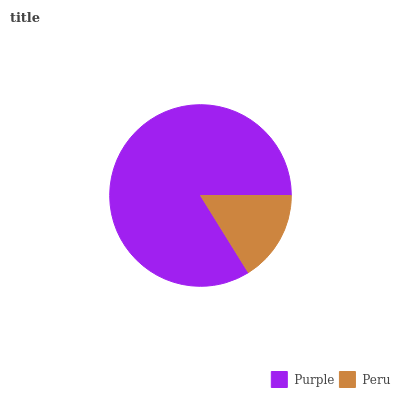Is Peru the minimum?
Answer yes or no. Yes. Is Purple the maximum?
Answer yes or no. Yes. Is Peru the maximum?
Answer yes or no. No. Is Purple greater than Peru?
Answer yes or no. Yes. Is Peru less than Purple?
Answer yes or no. Yes. Is Peru greater than Purple?
Answer yes or no. No. Is Purple less than Peru?
Answer yes or no. No. Is Purple the high median?
Answer yes or no. Yes. Is Peru the low median?
Answer yes or no. Yes. Is Peru the high median?
Answer yes or no. No. Is Purple the low median?
Answer yes or no. No. 